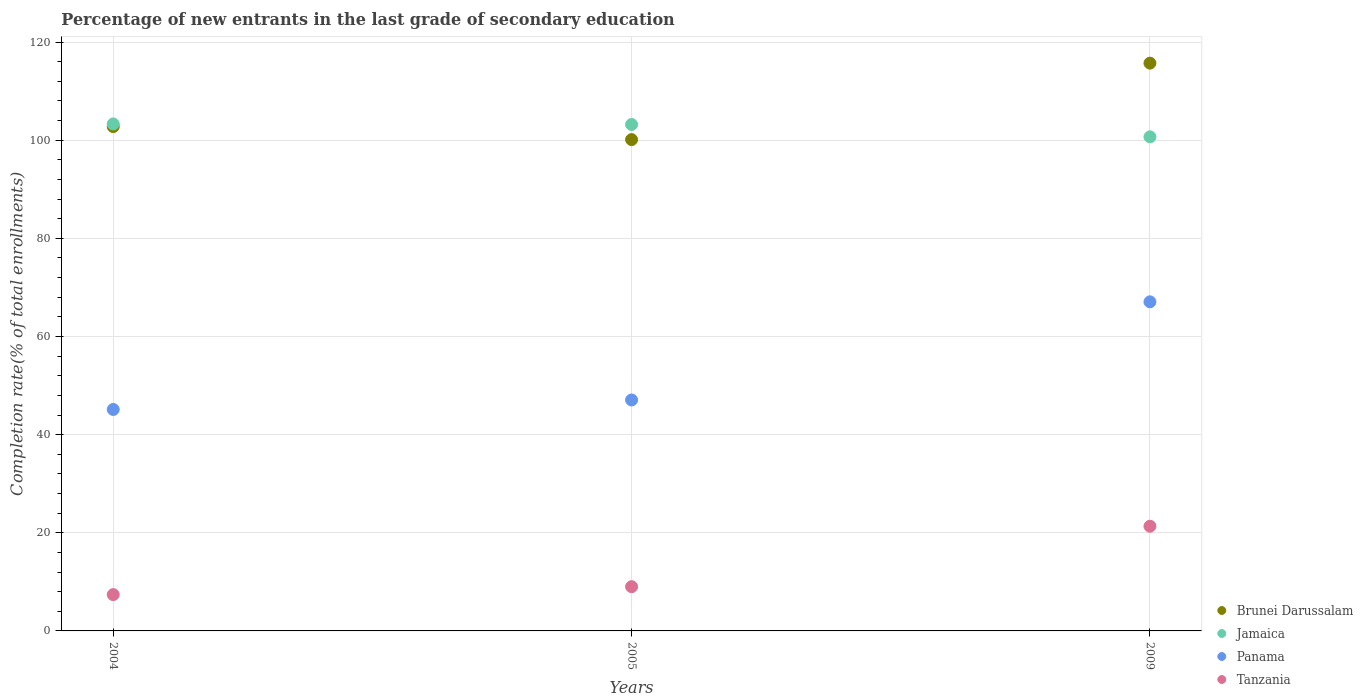Is the number of dotlines equal to the number of legend labels?
Your answer should be compact. Yes. What is the percentage of new entrants in Brunei Darussalam in 2009?
Make the answer very short. 115.7. Across all years, what is the maximum percentage of new entrants in Jamaica?
Make the answer very short. 103.31. Across all years, what is the minimum percentage of new entrants in Jamaica?
Offer a very short reply. 100.69. In which year was the percentage of new entrants in Brunei Darussalam minimum?
Provide a succinct answer. 2005. What is the total percentage of new entrants in Panama in the graph?
Keep it short and to the point. 159.26. What is the difference between the percentage of new entrants in Jamaica in 2004 and that in 2005?
Your answer should be very brief. 0.11. What is the difference between the percentage of new entrants in Jamaica in 2004 and the percentage of new entrants in Tanzania in 2009?
Offer a very short reply. 81.98. What is the average percentage of new entrants in Brunei Darussalam per year?
Give a very brief answer. 106.2. In the year 2009, what is the difference between the percentage of new entrants in Panama and percentage of new entrants in Brunei Darussalam?
Offer a terse response. -48.64. What is the ratio of the percentage of new entrants in Jamaica in 2004 to that in 2009?
Keep it short and to the point. 1.03. Is the difference between the percentage of new entrants in Panama in 2004 and 2009 greater than the difference between the percentage of new entrants in Brunei Darussalam in 2004 and 2009?
Offer a terse response. No. What is the difference between the highest and the second highest percentage of new entrants in Brunei Darussalam?
Your answer should be very brief. 12.93. What is the difference between the highest and the lowest percentage of new entrants in Tanzania?
Make the answer very short. 13.93. Is it the case that in every year, the sum of the percentage of new entrants in Jamaica and percentage of new entrants in Panama  is greater than the sum of percentage of new entrants in Brunei Darussalam and percentage of new entrants in Tanzania?
Give a very brief answer. No. Does the percentage of new entrants in Tanzania monotonically increase over the years?
Give a very brief answer. Yes. Is the percentage of new entrants in Panama strictly less than the percentage of new entrants in Jamaica over the years?
Give a very brief answer. Yes. How many years are there in the graph?
Make the answer very short. 3. Where does the legend appear in the graph?
Your answer should be compact. Bottom right. How many legend labels are there?
Provide a short and direct response. 4. What is the title of the graph?
Your answer should be compact. Percentage of new entrants in the last grade of secondary education. What is the label or title of the X-axis?
Offer a terse response. Years. What is the label or title of the Y-axis?
Offer a very short reply. Completion rate(% of total enrollments). What is the Completion rate(% of total enrollments) in Brunei Darussalam in 2004?
Your response must be concise. 102.77. What is the Completion rate(% of total enrollments) in Jamaica in 2004?
Provide a succinct answer. 103.31. What is the Completion rate(% of total enrollments) of Panama in 2004?
Keep it short and to the point. 45.13. What is the Completion rate(% of total enrollments) of Tanzania in 2004?
Give a very brief answer. 7.4. What is the Completion rate(% of total enrollments) in Brunei Darussalam in 2005?
Keep it short and to the point. 100.12. What is the Completion rate(% of total enrollments) of Jamaica in 2005?
Your answer should be compact. 103.2. What is the Completion rate(% of total enrollments) in Panama in 2005?
Your answer should be compact. 47.06. What is the Completion rate(% of total enrollments) in Tanzania in 2005?
Keep it short and to the point. 9.02. What is the Completion rate(% of total enrollments) of Brunei Darussalam in 2009?
Your response must be concise. 115.7. What is the Completion rate(% of total enrollments) in Jamaica in 2009?
Your answer should be compact. 100.69. What is the Completion rate(% of total enrollments) of Panama in 2009?
Provide a short and direct response. 67.06. What is the Completion rate(% of total enrollments) of Tanzania in 2009?
Your response must be concise. 21.33. Across all years, what is the maximum Completion rate(% of total enrollments) of Brunei Darussalam?
Provide a succinct answer. 115.7. Across all years, what is the maximum Completion rate(% of total enrollments) of Jamaica?
Provide a short and direct response. 103.31. Across all years, what is the maximum Completion rate(% of total enrollments) of Panama?
Provide a succinct answer. 67.06. Across all years, what is the maximum Completion rate(% of total enrollments) of Tanzania?
Offer a terse response. 21.33. Across all years, what is the minimum Completion rate(% of total enrollments) of Brunei Darussalam?
Provide a short and direct response. 100.12. Across all years, what is the minimum Completion rate(% of total enrollments) in Jamaica?
Offer a very short reply. 100.69. Across all years, what is the minimum Completion rate(% of total enrollments) of Panama?
Make the answer very short. 45.13. Across all years, what is the minimum Completion rate(% of total enrollments) of Tanzania?
Your response must be concise. 7.4. What is the total Completion rate(% of total enrollments) of Brunei Darussalam in the graph?
Your answer should be compact. 318.59. What is the total Completion rate(% of total enrollments) in Jamaica in the graph?
Make the answer very short. 307.2. What is the total Completion rate(% of total enrollments) in Panama in the graph?
Your answer should be very brief. 159.26. What is the total Completion rate(% of total enrollments) of Tanzania in the graph?
Offer a very short reply. 37.75. What is the difference between the Completion rate(% of total enrollments) of Brunei Darussalam in 2004 and that in 2005?
Give a very brief answer. 2.65. What is the difference between the Completion rate(% of total enrollments) in Jamaica in 2004 and that in 2005?
Keep it short and to the point. 0.11. What is the difference between the Completion rate(% of total enrollments) of Panama in 2004 and that in 2005?
Offer a very short reply. -1.93. What is the difference between the Completion rate(% of total enrollments) in Tanzania in 2004 and that in 2005?
Your answer should be compact. -1.61. What is the difference between the Completion rate(% of total enrollments) in Brunei Darussalam in 2004 and that in 2009?
Offer a terse response. -12.93. What is the difference between the Completion rate(% of total enrollments) of Jamaica in 2004 and that in 2009?
Provide a succinct answer. 2.63. What is the difference between the Completion rate(% of total enrollments) of Panama in 2004 and that in 2009?
Ensure brevity in your answer.  -21.94. What is the difference between the Completion rate(% of total enrollments) of Tanzania in 2004 and that in 2009?
Ensure brevity in your answer.  -13.93. What is the difference between the Completion rate(% of total enrollments) of Brunei Darussalam in 2005 and that in 2009?
Ensure brevity in your answer.  -15.58. What is the difference between the Completion rate(% of total enrollments) of Jamaica in 2005 and that in 2009?
Offer a terse response. 2.52. What is the difference between the Completion rate(% of total enrollments) of Panama in 2005 and that in 2009?
Your response must be concise. -20. What is the difference between the Completion rate(% of total enrollments) of Tanzania in 2005 and that in 2009?
Offer a very short reply. -12.32. What is the difference between the Completion rate(% of total enrollments) of Brunei Darussalam in 2004 and the Completion rate(% of total enrollments) of Jamaica in 2005?
Make the answer very short. -0.43. What is the difference between the Completion rate(% of total enrollments) of Brunei Darussalam in 2004 and the Completion rate(% of total enrollments) of Panama in 2005?
Provide a short and direct response. 55.71. What is the difference between the Completion rate(% of total enrollments) in Brunei Darussalam in 2004 and the Completion rate(% of total enrollments) in Tanzania in 2005?
Offer a terse response. 93.75. What is the difference between the Completion rate(% of total enrollments) of Jamaica in 2004 and the Completion rate(% of total enrollments) of Panama in 2005?
Provide a short and direct response. 56.25. What is the difference between the Completion rate(% of total enrollments) of Jamaica in 2004 and the Completion rate(% of total enrollments) of Tanzania in 2005?
Your response must be concise. 94.3. What is the difference between the Completion rate(% of total enrollments) in Panama in 2004 and the Completion rate(% of total enrollments) in Tanzania in 2005?
Your response must be concise. 36.11. What is the difference between the Completion rate(% of total enrollments) in Brunei Darussalam in 2004 and the Completion rate(% of total enrollments) in Jamaica in 2009?
Make the answer very short. 2.08. What is the difference between the Completion rate(% of total enrollments) in Brunei Darussalam in 2004 and the Completion rate(% of total enrollments) in Panama in 2009?
Provide a succinct answer. 35.71. What is the difference between the Completion rate(% of total enrollments) in Brunei Darussalam in 2004 and the Completion rate(% of total enrollments) in Tanzania in 2009?
Ensure brevity in your answer.  81.44. What is the difference between the Completion rate(% of total enrollments) in Jamaica in 2004 and the Completion rate(% of total enrollments) in Panama in 2009?
Provide a short and direct response. 36.25. What is the difference between the Completion rate(% of total enrollments) in Jamaica in 2004 and the Completion rate(% of total enrollments) in Tanzania in 2009?
Provide a succinct answer. 81.98. What is the difference between the Completion rate(% of total enrollments) of Panama in 2004 and the Completion rate(% of total enrollments) of Tanzania in 2009?
Provide a succinct answer. 23.79. What is the difference between the Completion rate(% of total enrollments) of Brunei Darussalam in 2005 and the Completion rate(% of total enrollments) of Jamaica in 2009?
Offer a very short reply. -0.57. What is the difference between the Completion rate(% of total enrollments) of Brunei Darussalam in 2005 and the Completion rate(% of total enrollments) of Panama in 2009?
Offer a very short reply. 33.05. What is the difference between the Completion rate(% of total enrollments) in Brunei Darussalam in 2005 and the Completion rate(% of total enrollments) in Tanzania in 2009?
Your answer should be very brief. 78.78. What is the difference between the Completion rate(% of total enrollments) in Jamaica in 2005 and the Completion rate(% of total enrollments) in Panama in 2009?
Offer a very short reply. 36.14. What is the difference between the Completion rate(% of total enrollments) of Jamaica in 2005 and the Completion rate(% of total enrollments) of Tanzania in 2009?
Make the answer very short. 81.87. What is the difference between the Completion rate(% of total enrollments) of Panama in 2005 and the Completion rate(% of total enrollments) of Tanzania in 2009?
Provide a succinct answer. 25.73. What is the average Completion rate(% of total enrollments) of Brunei Darussalam per year?
Offer a very short reply. 106.2. What is the average Completion rate(% of total enrollments) of Jamaica per year?
Offer a very short reply. 102.4. What is the average Completion rate(% of total enrollments) in Panama per year?
Your response must be concise. 53.09. What is the average Completion rate(% of total enrollments) of Tanzania per year?
Your answer should be very brief. 12.58. In the year 2004, what is the difference between the Completion rate(% of total enrollments) in Brunei Darussalam and Completion rate(% of total enrollments) in Jamaica?
Ensure brevity in your answer.  -0.54. In the year 2004, what is the difference between the Completion rate(% of total enrollments) of Brunei Darussalam and Completion rate(% of total enrollments) of Panama?
Your answer should be very brief. 57.64. In the year 2004, what is the difference between the Completion rate(% of total enrollments) of Brunei Darussalam and Completion rate(% of total enrollments) of Tanzania?
Make the answer very short. 95.37. In the year 2004, what is the difference between the Completion rate(% of total enrollments) of Jamaica and Completion rate(% of total enrollments) of Panama?
Provide a succinct answer. 58.19. In the year 2004, what is the difference between the Completion rate(% of total enrollments) of Jamaica and Completion rate(% of total enrollments) of Tanzania?
Offer a terse response. 95.91. In the year 2004, what is the difference between the Completion rate(% of total enrollments) in Panama and Completion rate(% of total enrollments) in Tanzania?
Your answer should be very brief. 37.73. In the year 2005, what is the difference between the Completion rate(% of total enrollments) in Brunei Darussalam and Completion rate(% of total enrollments) in Jamaica?
Your answer should be very brief. -3.08. In the year 2005, what is the difference between the Completion rate(% of total enrollments) of Brunei Darussalam and Completion rate(% of total enrollments) of Panama?
Offer a terse response. 53.05. In the year 2005, what is the difference between the Completion rate(% of total enrollments) in Brunei Darussalam and Completion rate(% of total enrollments) in Tanzania?
Your answer should be very brief. 91.1. In the year 2005, what is the difference between the Completion rate(% of total enrollments) in Jamaica and Completion rate(% of total enrollments) in Panama?
Your answer should be compact. 56.14. In the year 2005, what is the difference between the Completion rate(% of total enrollments) of Jamaica and Completion rate(% of total enrollments) of Tanzania?
Your response must be concise. 94.19. In the year 2005, what is the difference between the Completion rate(% of total enrollments) in Panama and Completion rate(% of total enrollments) in Tanzania?
Your answer should be compact. 38.05. In the year 2009, what is the difference between the Completion rate(% of total enrollments) of Brunei Darussalam and Completion rate(% of total enrollments) of Jamaica?
Provide a short and direct response. 15.02. In the year 2009, what is the difference between the Completion rate(% of total enrollments) of Brunei Darussalam and Completion rate(% of total enrollments) of Panama?
Your answer should be compact. 48.64. In the year 2009, what is the difference between the Completion rate(% of total enrollments) in Brunei Darussalam and Completion rate(% of total enrollments) in Tanzania?
Your response must be concise. 94.37. In the year 2009, what is the difference between the Completion rate(% of total enrollments) of Jamaica and Completion rate(% of total enrollments) of Panama?
Keep it short and to the point. 33.62. In the year 2009, what is the difference between the Completion rate(% of total enrollments) in Jamaica and Completion rate(% of total enrollments) in Tanzania?
Your response must be concise. 79.35. In the year 2009, what is the difference between the Completion rate(% of total enrollments) in Panama and Completion rate(% of total enrollments) in Tanzania?
Give a very brief answer. 45.73. What is the ratio of the Completion rate(% of total enrollments) of Brunei Darussalam in 2004 to that in 2005?
Provide a short and direct response. 1.03. What is the ratio of the Completion rate(% of total enrollments) of Panama in 2004 to that in 2005?
Provide a short and direct response. 0.96. What is the ratio of the Completion rate(% of total enrollments) of Tanzania in 2004 to that in 2005?
Make the answer very short. 0.82. What is the ratio of the Completion rate(% of total enrollments) of Brunei Darussalam in 2004 to that in 2009?
Make the answer very short. 0.89. What is the ratio of the Completion rate(% of total enrollments) of Jamaica in 2004 to that in 2009?
Your answer should be compact. 1.03. What is the ratio of the Completion rate(% of total enrollments) in Panama in 2004 to that in 2009?
Provide a succinct answer. 0.67. What is the ratio of the Completion rate(% of total enrollments) in Tanzania in 2004 to that in 2009?
Offer a terse response. 0.35. What is the ratio of the Completion rate(% of total enrollments) of Brunei Darussalam in 2005 to that in 2009?
Your answer should be very brief. 0.87. What is the ratio of the Completion rate(% of total enrollments) of Panama in 2005 to that in 2009?
Provide a succinct answer. 0.7. What is the ratio of the Completion rate(% of total enrollments) in Tanzania in 2005 to that in 2009?
Keep it short and to the point. 0.42. What is the difference between the highest and the second highest Completion rate(% of total enrollments) in Brunei Darussalam?
Offer a very short reply. 12.93. What is the difference between the highest and the second highest Completion rate(% of total enrollments) of Jamaica?
Keep it short and to the point. 0.11. What is the difference between the highest and the second highest Completion rate(% of total enrollments) of Panama?
Offer a terse response. 20. What is the difference between the highest and the second highest Completion rate(% of total enrollments) of Tanzania?
Offer a very short reply. 12.32. What is the difference between the highest and the lowest Completion rate(% of total enrollments) of Brunei Darussalam?
Make the answer very short. 15.58. What is the difference between the highest and the lowest Completion rate(% of total enrollments) of Jamaica?
Your answer should be very brief. 2.63. What is the difference between the highest and the lowest Completion rate(% of total enrollments) in Panama?
Give a very brief answer. 21.94. What is the difference between the highest and the lowest Completion rate(% of total enrollments) of Tanzania?
Provide a short and direct response. 13.93. 